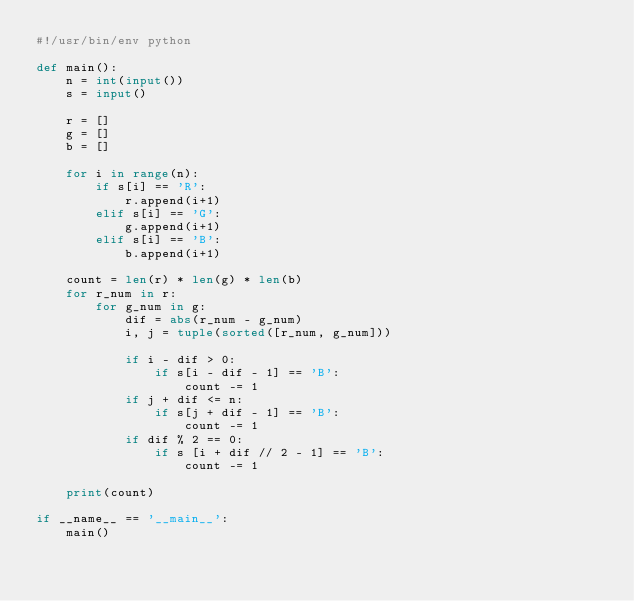Convert code to text. <code><loc_0><loc_0><loc_500><loc_500><_Python_>#!/usr/bin/env python

def main():
    n = int(input())
    s = input()

    r = []
    g = []
    b = []

    for i in range(n):
        if s[i] == 'R':
            r.append(i+1)
        elif s[i] == 'G':
            g.append(i+1)
        elif s[i] == 'B':
            b.append(i+1)

    count = len(r) * len(g) * len(b)
    for r_num in r:
        for g_num in g:
            dif = abs(r_num - g_num)
            i, j = tuple(sorted([r_num, g_num]))

            if i - dif > 0:
                if s[i - dif - 1] == 'B':
                    count -= 1
            if j + dif <= n:
                if s[j + dif - 1] == 'B':
                    count -= 1
            if dif % 2 == 0:
                if s [i + dif // 2 - 1] == 'B':
                    count -= 1

    print(count)

if __name__ == '__main__':
    main()
</code> 